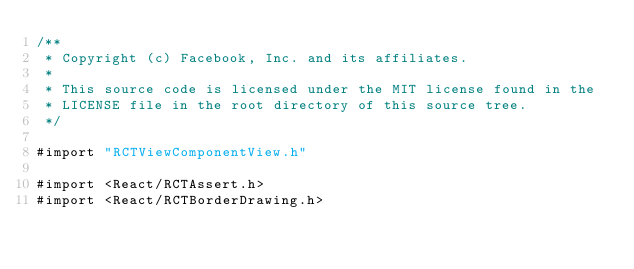Convert code to text. <code><loc_0><loc_0><loc_500><loc_500><_ObjectiveC_>/**
 * Copyright (c) Facebook, Inc. and its affiliates.
 *
 * This source code is licensed under the MIT license found in the
 * LICENSE file in the root directory of this source tree.
 */

#import "RCTViewComponentView.h"

#import <React/RCTAssert.h>
#import <React/RCTBorderDrawing.h></code> 